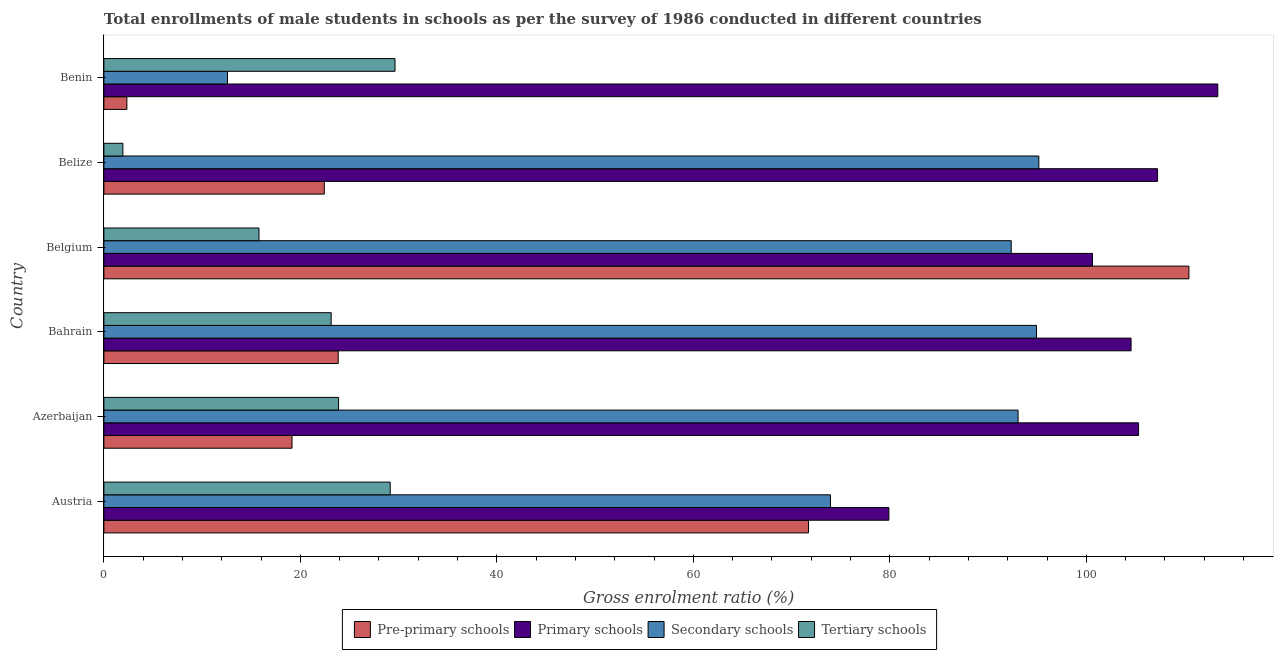Are the number of bars per tick equal to the number of legend labels?
Make the answer very short. Yes. Are the number of bars on each tick of the Y-axis equal?
Your answer should be compact. Yes. How many bars are there on the 4th tick from the top?
Your response must be concise. 4. How many bars are there on the 1st tick from the bottom?
Provide a short and direct response. 4. What is the label of the 2nd group of bars from the top?
Ensure brevity in your answer.  Belize. In how many cases, is the number of bars for a given country not equal to the number of legend labels?
Ensure brevity in your answer.  0. What is the gross enrolment ratio(male) in primary schools in Austria?
Your answer should be compact. 79.9. Across all countries, what is the maximum gross enrolment ratio(male) in primary schools?
Make the answer very short. 113.38. Across all countries, what is the minimum gross enrolment ratio(male) in pre-primary schools?
Provide a short and direct response. 2.34. In which country was the gross enrolment ratio(male) in primary schools maximum?
Provide a short and direct response. Benin. What is the total gross enrolment ratio(male) in pre-primary schools in the graph?
Give a very brief answer. 249.94. What is the difference between the gross enrolment ratio(male) in secondary schools in Belize and that in Benin?
Your answer should be compact. 82.59. What is the difference between the gross enrolment ratio(male) in primary schools in Benin and the gross enrolment ratio(male) in tertiary schools in Belgium?
Your answer should be compact. 97.59. What is the average gross enrolment ratio(male) in pre-primary schools per country?
Ensure brevity in your answer.  41.66. What is the difference between the gross enrolment ratio(male) in secondary schools and gross enrolment ratio(male) in pre-primary schools in Belgium?
Your response must be concise. -18.09. In how many countries, is the gross enrolment ratio(male) in tertiary schools greater than 36 %?
Offer a very short reply. 0. What is the ratio of the gross enrolment ratio(male) in pre-primary schools in Austria to that in Azerbaijan?
Keep it short and to the point. 3.75. Is the difference between the gross enrolment ratio(male) in secondary schools in Belgium and Belize greater than the difference between the gross enrolment ratio(male) in primary schools in Belgium and Belize?
Make the answer very short. Yes. What is the difference between the highest and the second highest gross enrolment ratio(male) in primary schools?
Offer a very short reply. 6.13. What is the difference between the highest and the lowest gross enrolment ratio(male) in tertiary schools?
Provide a succinct answer. 27.7. In how many countries, is the gross enrolment ratio(male) in tertiary schools greater than the average gross enrolment ratio(male) in tertiary schools taken over all countries?
Give a very brief answer. 4. Is it the case that in every country, the sum of the gross enrolment ratio(male) in pre-primary schools and gross enrolment ratio(male) in secondary schools is greater than the sum of gross enrolment ratio(male) in primary schools and gross enrolment ratio(male) in tertiary schools?
Your response must be concise. No. What does the 4th bar from the top in Belize represents?
Give a very brief answer. Pre-primary schools. What does the 3rd bar from the bottom in Belgium represents?
Offer a terse response. Secondary schools. Is it the case that in every country, the sum of the gross enrolment ratio(male) in pre-primary schools and gross enrolment ratio(male) in primary schools is greater than the gross enrolment ratio(male) in secondary schools?
Offer a terse response. Yes. How many countries are there in the graph?
Make the answer very short. 6. What is the difference between two consecutive major ticks on the X-axis?
Your answer should be compact. 20. Are the values on the major ticks of X-axis written in scientific E-notation?
Your answer should be very brief. No. Does the graph contain any zero values?
Provide a short and direct response. No. How are the legend labels stacked?
Make the answer very short. Horizontal. What is the title of the graph?
Offer a very short reply. Total enrollments of male students in schools as per the survey of 1986 conducted in different countries. Does "Finland" appear as one of the legend labels in the graph?
Keep it short and to the point. No. What is the Gross enrolment ratio (%) in Pre-primary schools in Austria?
Provide a short and direct response. 71.72. What is the Gross enrolment ratio (%) in Primary schools in Austria?
Your answer should be compact. 79.9. What is the Gross enrolment ratio (%) of Secondary schools in Austria?
Provide a succinct answer. 73.96. What is the Gross enrolment ratio (%) of Tertiary schools in Austria?
Provide a short and direct response. 29.14. What is the Gross enrolment ratio (%) of Pre-primary schools in Azerbaijan?
Provide a succinct answer. 19.15. What is the Gross enrolment ratio (%) of Primary schools in Azerbaijan?
Provide a short and direct response. 105.32. What is the Gross enrolment ratio (%) in Secondary schools in Azerbaijan?
Your response must be concise. 93.05. What is the Gross enrolment ratio (%) in Tertiary schools in Azerbaijan?
Ensure brevity in your answer.  23.89. What is the Gross enrolment ratio (%) of Pre-primary schools in Bahrain?
Offer a terse response. 23.85. What is the Gross enrolment ratio (%) in Primary schools in Bahrain?
Your answer should be very brief. 104.55. What is the Gross enrolment ratio (%) of Secondary schools in Bahrain?
Keep it short and to the point. 94.93. What is the Gross enrolment ratio (%) in Tertiary schools in Bahrain?
Your answer should be very brief. 23.13. What is the Gross enrolment ratio (%) in Pre-primary schools in Belgium?
Your answer should be compact. 110.44. What is the Gross enrolment ratio (%) in Primary schools in Belgium?
Make the answer very short. 100.63. What is the Gross enrolment ratio (%) in Secondary schools in Belgium?
Ensure brevity in your answer.  92.35. What is the Gross enrolment ratio (%) of Tertiary schools in Belgium?
Ensure brevity in your answer.  15.79. What is the Gross enrolment ratio (%) of Pre-primary schools in Belize?
Provide a short and direct response. 22.43. What is the Gross enrolment ratio (%) in Primary schools in Belize?
Your answer should be compact. 107.25. What is the Gross enrolment ratio (%) in Secondary schools in Belize?
Provide a short and direct response. 95.17. What is the Gross enrolment ratio (%) of Tertiary schools in Belize?
Make the answer very short. 1.93. What is the Gross enrolment ratio (%) of Pre-primary schools in Benin?
Provide a short and direct response. 2.34. What is the Gross enrolment ratio (%) in Primary schools in Benin?
Give a very brief answer. 113.38. What is the Gross enrolment ratio (%) of Secondary schools in Benin?
Make the answer very short. 12.58. What is the Gross enrolment ratio (%) of Tertiary schools in Benin?
Your answer should be compact. 29.63. Across all countries, what is the maximum Gross enrolment ratio (%) of Pre-primary schools?
Your answer should be compact. 110.44. Across all countries, what is the maximum Gross enrolment ratio (%) in Primary schools?
Offer a terse response. 113.38. Across all countries, what is the maximum Gross enrolment ratio (%) in Secondary schools?
Provide a short and direct response. 95.17. Across all countries, what is the maximum Gross enrolment ratio (%) in Tertiary schools?
Give a very brief answer. 29.63. Across all countries, what is the minimum Gross enrolment ratio (%) in Pre-primary schools?
Provide a succinct answer. 2.34. Across all countries, what is the minimum Gross enrolment ratio (%) in Primary schools?
Your answer should be very brief. 79.9. Across all countries, what is the minimum Gross enrolment ratio (%) of Secondary schools?
Keep it short and to the point. 12.58. Across all countries, what is the minimum Gross enrolment ratio (%) of Tertiary schools?
Provide a succinct answer. 1.93. What is the total Gross enrolment ratio (%) in Pre-primary schools in the graph?
Offer a terse response. 249.94. What is the total Gross enrolment ratio (%) in Primary schools in the graph?
Offer a terse response. 611.03. What is the total Gross enrolment ratio (%) in Secondary schools in the graph?
Offer a very short reply. 462.04. What is the total Gross enrolment ratio (%) in Tertiary schools in the graph?
Your answer should be very brief. 123.52. What is the difference between the Gross enrolment ratio (%) in Pre-primary schools in Austria and that in Azerbaijan?
Provide a succinct answer. 52.58. What is the difference between the Gross enrolment ratio (%) of Primary schools in Austria and that in Azerbaijan?
Offer a very short reply. -25.41. What is the difference between the Gross enrolment ratio (%) of Secondary schools in Austria and that in Azerbaijan?
Your answer should be very brief. -19.1. What is the difference between the Gross enrolment ratio (%) in Tertiary schools in Austria and that in Azerbaijan?
Offer a terse response. 5.26. What is the difference between the Gross enrolment ratio (%) in Pre-primary schools in Austria and that in Bahrain?
Provide a short and direct response. 47.87. What is the difference between the Gross enrolment ratio (%) in Primary schools in Austria and that in Bahrain?
Ensure brevity in your answer.  -24.65. What is the difference between the Gross enrolment ratio (%) in Secondary schools in Austria and that in Bahrain?
Keep it short and to the point. -20.97. What is the difference between the Gross enrolment ratio (%) of Tertiary schools in Austria and that in Bahrain?
Provide a short and direct response. 6.01. What is the difference between the Gross enrolment ratio (%) in Pre-primary schools in Austria and that in Belgium?
Your answer should be very brief. -38.72. What is the difference between the Gross enrolment ratio (%) of Primary schools in Austria and that in Belgium?
Provide a succinct answer. -20.73. What is the difference between the Gross enrolment ratio (%) of Secondary schools in Austria and that in Belgium?
Your answer should be compact. -18.4. What is the difference between the Gross enrolment ratio (%) in Tertiary schools in Austria and that in Belgium?
Keep it short and to the point. 13.36. What is the difference between the Gross enrolment ratio (%) in Pre-primary schools in Austria and that in Belize?
Offer a very short reply. 49.29. What is the difference between the Gross enrolment ratio (%) of Primary schools in Austria and that in Belize?
Ensure brevity in your answer.  -27.35. What is the difference between the Gross enrolment ratio (%) of Secondary schools in Austria and that in Belize?
Your answer should be very brief. -21.21. What is the difference between the Gross enrolment ratio (%) in Tertiary schools in Austria and that in Belize?
Your answer should be compact. 27.21. What is the difference between the Gross enrolment ratio (%) of Pre-primary schools in Austria and that in Benin?
Keep it short and to the point. 69.38. What is the difference between the Gross enrolment ratio (%) in Primary schools in Austria and that in Benin?
Give a very brief answer. -33.48. What is the difference between the Gross enrolment ratio (%) of Secondary schools in Austria and that in Benin?
Give a very brief answer. 61.38. What is the difference between the Gross enrolment ratio (%) in Tertiary schools in Austria and that in Benin?
Keep it short and to the point. -0.49. What is the difference between the Gross enrolment ratio (%) in Pre-primary schools in Azerbaijan and that in Bahrain?
Provide a short and direct response. -4.7. What is the difference between the Gross enrolment ratio (%) of Primary schools in Azerbaijan and that in Bahrain?
Offer a very short reply. 0.76. What is the difference between the Gross enrolment ratio (%) of Secondary schools in Azerbaijan and that in Bahrain?
Your answer should be compact. -1.88. What is the difference between the Gross enrolment ratio (%) of Tertiary schools in Azerbaijan and that in Bahrain?
Keep it short and to the point. 0.75. What is the difference between the Gross enrolment ratio (%) of Pre-primary schools in Azerbaijan and that in Belgium?
Your response must be concise. -91.29. What is the difference between the Gross enrolment ratio (%) of Primary schools in Azerbaijan and that in Belgium?
Offer a terse response. 4.69. What is the difference between the Gross enrolment ratio (%) in Secondary schools in Azerbaijan and that in Belgium?
Offer a terse response. 0.7. What is the difference between the Gross enrolment ratio (%) in Tertiary schools in Azerbaijan and that in Belgium?
Offer a very short reply. 8.1. What is the difference between the Gross enrolment ratio (%) of Pre-primary schools in Azerbaijan and that in Belize?
Your answer should be compact. -3.29. What is the difference between the Gross enrolment ratio (%) in Primary schools in Azerbaijan and that in Belize?
Your response must be concise. -1.93. What is the difference between the Gross enrolment ratio (%) of Secondary schools in Azerbaijan and that in Belize?
Keep it short and to the point. -2.11. What is the difference between the Gross enrolment ratio (%) of Tertiary schools in Azerbaijan and that in Belize?
Provide a short and direct response. 21.96. What is the difference between the Gross enrolment ratio (%) in Pre-primary schools in Azerbaijan and that in Benin?
Your answer should be compact. 16.81. What is the difference between the Gross enrolment ratio (%) in Primary schools in Azerbaijan and that in Benin?
Your answer should be very brief. -8.07. What is the difference between the Gross enrolment ratio (%) of Secondary schools in Azerbaijan and that in Benin?
Give a very brief answer. 80.47. What is the difference between the Gross enrolment ratio (%) in Tertiary schools in Azerbaijan and that in Benin?
Your response must be concise. -5.75. What is the difference between the Gross enrolment ratio (%) of Pre-primary schools in Bahrain and that in Belgium?
Your response must be concise. -86.59. What is the difference between the Gross enrolment ratio (%) of Primary schools in Bahrain and that in Belgium?
Offer a terse response. 3.93. What is the difference between the Gross enrolment ratio (%) in Secondary schools in Bahrain and that in Belgium?
Your answer should be compact. 2.57. What is the difference between the Gross enrolment ratio (%) in Tertiary schools in Bahrain and that in Belgium?
Keep it short and to the point. 7.35. What is the difference between the Gross enrolment ratio (%) in Pre-primary schools in Bahrain and that in Belize?
Provide a succinct answer. 1.42. What is the difference between the Gross enrolment ratio (%) of Primary schools in Bahrain and that in Belize?
Keep it short and to the point. -2.7. What is the difference between the Gross enrolment ratio (%) in Secondary schools in Bahrain and that in Belize?
Provide a short and direct response. -0.24. What is the difference between the Gross enrolment ratio (%) in Tertiary schools in Bahrain and that in Belize?
Keep it short and to the point. 21.2. What is the difference between the Gross enrolment ratio (%) in Pre-primary schools in Bahrain and that in Benin?
Provide a succinct answer. 21.51. What is the difference between the Gross enrolment ratio (%) of Primary schools in Bahrain and that in Benin?
Ensure brevity in your answer.  -8.83. What is the difference between the Gross enrolment ratio (%) in Secondary schools in Bahrain and that in Benin?
Give a very brief answer. 82.35. What is the difference between the Gross enrolment ratio (%) in Tertiary schools in Bahrain and that in Benin?
Offer a very short reply. -6.5. What is the difference between the Gross enrolment ratio (%) in Pre-primary schools in Belgium and that in Belize?
Offer a very short reply. 88.01. What is the difference between the Gross enrolment ratio (%) in Primary schools in Belgium and that in Belize?
Your response must be concise. -6.62. What is the difference between the Gross enrolment ratio (%) in Secondary schools in Belgium and that in Belize?
Your response must be concise. -2.81. What is the difference between the Gross enrolment ratio (%) of Tertiary schools in Belgium and that in Belize?
Offer a terse response. 13.85. What is the difference between the Gross enrolment ratio (%) in Pre-primary schools in Belgium and that in Benin?
Provide a short and direct response. 108.1. What is the difference between the Gross enrolment ratio (%) of Primary schools in Belgium and that in Benin?
Your response must be concise. -12.75. What is the difference between the Gross enrolment ratio (%) of Secondary schools in Belgium and that in Benin?
Make the answer very short. 79.77. What is the difference between the Gross enrolment ratio (%) of Tertiary schools in Belgium and that in Benin?
Provide a short and direct response. -13.85. What is the difference between the Gross enrolment ratio (%) in Pre-primary schools in Belize and that in Benin?
Ensure brevity in your answer.  20.09. What is the difference between the Gross enrolment ratio (%) in Primary schools in Belize and that in Benin?
Provide a succinct answer. -6.13. What is the difference between the Gross enrolment ratio (%) in Secondary schools in Belize and that in Benin?
Provide a short and direct response. 82.59. What is the difference between the Gross enrolment ratio (%) of Tertiary schools in Belize and that in Benin?
Your answer should be very brief. -27.7. What is the difference between the Gross enrolment ratio (%) of Pre-primary schools in Austria and the Gross enrolment ratio (%) of Primary schools in Azerbaijan?
Ensure brevity in your answer.  -33.59. What is the difference between the Gross enrolment ratio (%) in Pre-primary schools in Austria and the Gross enrolment ratio (%) in Secondary schools in Azerbaijan?
Ensure brevity in your answer.  -21.33. What is the difference between the Gross enrolment ratio (%) of Pre-primary schools in Austria and the Gross enrolment ratio (%) of Tertiary schools in Azerbaijan?
Keep it short and to the point. 47.84. What is the difference between the Gross enrolment ratio (%) of Primary schools in Austria and the Gross enrolment ratio (%) of Secondary schools in Azerbaijan?
Your answer should be very brief. -13.15. What is the difference between the Gross enrolment ratio (%) of Primary schools in Austria and the Gross enrolment ratio (%) of Tertiary schools in Azerbaijan?
Offer a terse response. 56.01. What is the difference between the Gross enrolment ratio (%) of Secondary schools in Austria and the Gross enrolment ratio (%) of Tertiary schools in Azerbaijan?
Give a very brief answer. 50.07. What is the difference between the Gross enrolment ratio (%) in Pre-primary schools in Austria and the Gross enrolment ratio (%) in Primary schools in Bahrain?
Ensure brevity in your answer.  -32.83. What is the difference between the Gross enrolment ratio (%) in Pre-primary schools in Austria and the Gross enrolment ratio (%) in Secondary schools in Bahrain?
Your answer should be very brief. -23.21. What is the difference between the Gross enrolment ratio (%) in Pre-primary schools in Austria and the Gross enrolment ratio (%) in Tertiary schools in Bahrain?
Provide a short and direct response. 48.59. What is the difference between the Gross enrolment ratio (%) in Primary schools in Austria and the Gross enrolment ratio (%) in Secondary schools in Bahrain?
Provide a short and direct response. -15.03. What is the difference between the Gross enrolment ratio (%) of Primary schools in Austria and the Gross enrolment ratio (%) of Tertiary schools in Bahrain?
Offer a very short reply. 56.77. What is the difference between the Gross enrolment ratio (%) of Secondary schools in Austria and the Gross enrolment ratio (%) of Tertiary schools in Bahrain?
Offer a very short reply. 50.82. What is the difference between the Gross enrolment ratio (%) in Pre-primary schools in Austria and the Gross enrolment ratio (%) in Primary schools in Belgium?
Keep it short and to the point. -28.9. What is the difference between the Gross enrolment ratio (%) in Pre-primary schools in Austria and the Gross enrolment ratio (%) in Secondary schools in Belgium?
Provide a short and direct response. -20.63. What is the difference between the Gross enrolment ratio (%) of Pre-primary schools in Austria and the Gross enrolment ratio (%) of Tertiary schools in Belgium?
Your answer should be very brief. 55.94. What is the difference between the Gross enrolment ratio (%) of Primary schools in Austria and the Gross enrolment ratio (%) of Secondary schools in Belgium?
Give a very brief answer. -12.45. What is the difference between the Gross enrolment ratio (%) of Primary schools in Austria and the Gross enrolment ratio (%) of Tertiary schools in Belgium?
Offer a terse response. 64.11. What is the difference between the Gross enrolment ratio (%) in Secondary schools in Austria and the Gross enrolment ratio (%) in Tertiary schools in Belgium?
Offer a very short reply. 58.17. What is the difference between the Gross enrolment ratio (%) in Pre-primary schools in Austria and the Gross enrolment ratio (%) in Primary schools in Belize?
Your response must be concise. -35.53. What is the difference between the Gross enrolment ratio (%) in Pre-primary schools in Austria and the Gross enrolment ratio (%) in Secondary schools in Belize?
Your response must be concise. -23.44. What is the difference between the Gross enrolment ratio (%) of Pre-primary schools in Austria and the Gross enrolment ratio (%) of Tertiary schools in Belize?
Your answer should be compact. 69.79. What is the difference between the Gross enrolment ratio (%) of Primary schools in Austria and the Gross enrolment ratio (%) of Secondary schools in Belize?
Ensure brevity in your answer.  -15.27. What is the difference between the Gross enrolment ratio (%) in Primary schools in Austria and the Gross enrolment ratio (%) in Tertiary schools in Belize?
Provide a short and direct response. 77.97. What is the difference between the Gross enrolment ratio (%) of Secondary schools in Austria and the Gross enrolment ratio (%) of Tertiary schools in Belize?
Offer a very short reply. 72.02. What is the difference between the Gross enrolment ratio (%) of Pre-primary schools in Austria and the Gross enrolment ratio (%) of Primary schools in Benin?
Ensure brevity in your answer.  -41.66. What is the difference between the Gross enrolment ratio (%) of Pre-primary schools in Austria and the Gross enrolment ratio (%) of Secondary schools in Benin?
Keep it short and to the point. 59.14. What is the difference between the Gross enrolment ratio (%) in Pre-primary schools in Austria and the Gross enrolment ratio (%) in Tertiary schools in Benin?
Offer a very short reply. 42.09. What is the difference between the Gross enrolment ratio (%) of Primary schools in Austria and the Gross enrolment ratio (%) of Secondary schools in Benin?
Keep it short and to the point. 67.32. What is the difference between the Gross enrolment ratio (%) in Primary schools in Austria and the Gross enrolment ratio (%) in Tertiary schools in Benin?
Your answer should be compact. 50.27. What is the difference between the Gross enrolment ratio (%) in Secondary schools in Austria and the Gross enrolment ratio (%) in Tertiary schools in Benin?
Your answer should be compact. 44.32. What is the difference between the Gross enrolment ratio (%) of Pre-primary schools in Azerbaijan and the Gross enrolment ratio (%) of Primary schools in Bahrain?
Your response must be concise. -85.41. What is the difference between the Gross enrolment ratio (%) in Pre-primary schools in Azerbaijan and the Gross enrolment ratio (%) in Secondary schools in Bahrain?
Make the answer very short. -75.78. What is the difference between the Gross enrolment ratio (%) of Pre-primary schools in Azerbaijan and the Gross enrolment ratio (%) of Tertiary schools in Bahrain?
Provide a succinct answer. -3.99. What is the difference between the Gross enrolment ratio (%) of Primary schools in Azerbaijan and the Gross enrolment ratio (%) of Secondary schools in Bahrain?
Give a very brief answer. 10.39. What is the difference between the Gross enrolment ratio (%) in Primary schools in Azerbaijan and the Gross enrolment ratio (%) in Tertiary schools in Bahrain?
Offer a very short reply. 82.18. What is the difference between the Gross enrolment ratio (%) of Secondary schools in Azerbaijan and the Gross enrolment ratio (%) of Tertiary schools in Bahrain?
Make the answer very short. 69.92. What is the difference between the Gross enrolment ratio (%) of Pre-primary schools in Azerbaijan and the Gross enrolment ratio (%) of Primary schools in Belgium?
Provide a short and direct response. -81.48. What is the difference between the Gross enrolment ratio (%) in Pre-primary schools in Azerbaijan and the Gross enrolment ratio (%) in Secondary schools in Belgium?
Ensure brevity in your answer.  -73.21. What is the difference between the Gross enrolment ratio (%) of Pre-primary schools in Azerbaijan and the Gross enrolment ratio (%) of Tertiary schools in Belgium?
Offer a very short reply. 3.36. What is the difference between the Gross enrolment ratio (%) of Primary schools in Azerbaijan and the Gross enrolment ratio (%) of Secondary schools in Belgium?
Keep it short and to the point. 12.96. What is the difference between the Gross enrolment ratio (%) of Primary schools in Azerbaijan and the Gross enrolment ratio (%) of Tertiary schools in Belgium?
Provide a short and direct response. 89.53. What is the difference between the Gross enrolment ratio (%) of Secondary schools in Azerbaijan and the Gross enrolment ratio (%) of Tertiary schools in Belgium?
Offer a terse response. 77.27. What is the difference between the Gross enrolment ratio (%) of Pre-primary schools in Azerbaijan and the Gross enrolment ratio (%) of Primary schools in Belize?
Provide a succinct answer. -88.1. What is the difference between the Gross enrolment ratio (%) of Pre-primary schools in Azerbaijan and the Gross enrolment ratio (%) of Secondary schools in Belize?
Provide a short and direct response. -76.02. What is the difference between the Gross enrolment ratio (%) of Pre-primary schools in Azerbaijan and the Gross enrolment ratio (%) of Tertiary schools in Belize?
Keep it short and to the point. 17.22. What is the difference between the Gross enrolment ratio (%) of Primary schools in Azerbaijan and the Gross enrolment ratio (%) of Secondary schools in Belize?
Provide a short and direct response. 10.15. What is the difference between the Gross enrolment ratio (%) in Primary schools in Azerbaijan and the Gross enrolment ratio (%) in Tertiary schools in Belize?
Provide a succinct answer. 103.38. What is the difference between the Gross enrolment ratio (%) in Secondary schools in Azerbaijan and the Gross enrolment ratio (%) in Tertiary schools in Belize?
Keep it short and to the point. 91.12. What is the difference between the Gross enrolment ratio (%) in Pre-primary schools in Azerbaijan and the Gross enrolment ratio (%) in Primary schools in Benin?
Provide a succinct answer. -94.23. What is the difference between the Gross enrolment ratio (%) of Pre-primary schools in Azerbaijan and the Gross enrolment ratio (%) of Secondary schools in Benin?
Your answer should be compact. 6.57. What is the difference between the Gross enrolment ratio (%) in Pre-primary schools in Azerbaijan and the Gross enrolment ratio (%) in Tertiary schools in Benin?
Offer a terse response. -10.49. What is the difference between the Gross enrolment ratio (%) in Primary schools in Azerbaijan and the Gross enrolment ratio (%) in Secondary schools in Benin?
Your response must be concise. 92.74. What is the difference between the Gross enrolment ratio (%) in Primary schools in Azerbaijan and the Gross enrolment ratio (%) in Tertiary schools in Benin?
Your response must be concise. 75.68. What is the difference between the Gross enrolment ratio (%) in Secondary schools in Azerbaijan and the Gross enrolment ratio (%) in Tertiary schools in Benin?
Give a very brief answer. 63.42. What is the difference between the Gross enrolment ratio (%) in Pre-primary schools in Bahrain and the Gross enrolment ratio (%) in Primary schools in Belgium?
Make the answer very short. -76.78. What is the difference between the Gross enrolment ratio (%) in Pre-primary schools in Bahrain and the Gross enrolment ratio (%) in Secondary schools in Belgium?
Your answer should be very brief. -68.5. What is the difference between the Gross enrolment ratio (%) of Pre-primary schools in Bahrain and the Gross enrolment ratio (%) of Tertiary schools in Belgium?
Your response must be concise. 8.06. What is the difference between the Gross enrolment ratio (%) in Primary schools in Bahrain and the Gross enrolment ratio (%) in Secondary schools in Belgium?
Your answer should be compact. 12.2. What is the difference between the Gross enrolment ratio (%) in Primary schools in Bahrain and the Gross enrolment ratio (%) in Tertiary schools in Belgium?
Give a very brief answer. 88.77. What is the difference between the Gross enrolment ratio (%) in Secondary schools in Bahrain and the Gross enrolment ratio (%) in Tertiary schools in Belgium?
Provide a succinct answer. 79.14. What is the difference between the Gross enrolment ratio (%) of Pre-primary schools in Bahrain and the Gross enrolment ratio (%) of Primary schools in Belize?
Make the answer very short. -83.4. What is the difference between the Gross enrolment ratio (%) in Pre-primary schools in Bahrain and the Gross enrolment ratio (%) in Secondary schools in Belize?
Provide a short and direct response. -71.32. What is the difference between the Gross enrolment ratio (%) of Pre-primary schools in Bahrain and the Gross enrolment ratio (%) of Tertiary schools in Belize?
Keep it short and to the point. 21.92. What is the difference between the Gross enrolment ratio (%) in Primary schools in Bahrain and the Gross enrolment ratio (%) in Secondary schools in Belize?
Offer a terse response. 9.39. What is the difference between the Gross enrolment ratio (%) of Primary schools in Bahrain and the Gross enrolment ratio (%) of Tertiary schools in Belize?
Offer a very short reply. 102.62. What is the difference between the Gross enrolment ratio (%) in Secondary schools in Bahrain and the Gross enrolment ratio (%) in Tertiary schools in Belize?
Make the answer very short. 93. What is the difference between the Gross enrolment ratio (%) in Pre-primary schools in Bahrain and the Gross enrolment ratio (%) in Primary schools in Benin?
Your answer should be compact. -89.53. What is the difference between the Gross enrolment ratio (%) of Pre-primary schools in Bahrain and the Gross enrolment ratio (%) of Secondary schools in Benin?
Offer a very short reply. 11.27. What is the difference between the Gross enrolment ratio (%) of Pre-primary schools in Bahrain and the Gross enrolment ratio (%) of Tertiary schools in Benin?
Give a very brief answer. -5.78. What is the difference between the Gross enrolment ratio (%) of Primary schools in Bahrain and the Gross enrolment ratio (%) of Secondary schools in Benin?
Provide a short and direct response. 91.97. What is the difference between the Gross enrolment ratio (%) of Primary schools in Bahrain and the Gross enrolment ratio (%) of Tertiary schools in Benin?
Make the answer very short. 74.92. What is the difference between the Gross enrolment ratio (%) in Secondary schools in Bahrain and the Gross enrolment ratio (%) in Tertiary schools in Benin?
Offer a terse response. 65.3. What is the difference between the Gross enrolment ratio (%) in Pre-primary schools in Belgium and the Gross enrolment ratio (%) in Primary schools in Belize?
Your response must be concise. 3.19. What is the difference between the Gross enrolment ratio (%) in Pre-primary schools in Belgium and the Gross enrolment ratio (%) in Secondary schools in Belize?
Give a very brief answer. 15.28. What is the difference between the Gross enrolment ratio (%) of Pre-primary schools in Belgium and the Gross enrolment ratio (%) of Tertiary schools in Belize?
Your answer should be compact. 108.51. What is the difference between the Gross enrolment ratio (%) of Primary schools in Belgium and the Gross enrolment ratio (%) of Secondary schools in Belize?
Keep it short and to the point. 5.46. What is the difference between the Gross enrolment ratio (%) in Primary schools in Belgium and the Gross enrolment ratio (%) in Tertiary schools in Belize?
Keep it short and to the point. 98.7. What is the difference between the Gross enrolment ratio (%) of Secondary schools in Belgium and the Gross enrolment ratio (%) of Tertiary schools in Belize?
Make the answer very short. 90.42. What is the difference between the Gross enrolment ratio (%) of Pre-primary schools in Belgium and the Gross enrolment ratio (%) of Primary schools in Benin?
Ensure brevity in your answer.  -2.94. What is the difference between the Gross enrolment ratio (%) of Pre-primary schools in Belgium and the Gross enrolment ratio (%) of Secondary schools in Benin?
Offer a terse response. 97.86. What is the difference between the Gross enrolment ratio (%) of Pre-primary schools in Belgium and the Gross enrolment ratio (%) of Tertiary schools in Benin?
Provide a short and direct response. 80.81. What is the difference between the Gross enrolment ratio (%) of Primary schools in Belgium and the Gross enrolment ratio (%) of Secondary schools in Benin?
Ensure brevity in your answer.  88.05. What is the difference between the Gross enrolment ratio (%) of Primary schools in Belgium and the Gross enrolment ratio (%) of Tertiary schools in Benin?
Ensure brevity in your answer.  71. What is the difference between the Gross enrolment ratio (%) in Secondary schools in Belgium and the Gross enrolment ratio (%) in Tertiary schools in Benin?
Give a very brief answer. 62.72. What is the difference between the Gross enrolment ratio (%) of Pre-primary schools in Belize and the Gross enrolment ratio (%) of Primary schools in Benin?
Your response must be concise. -90.95. What is the difference between the Gross enrolment ratio (%) in Pre-primary schools in Belize and the Gross enrolment ratio (%) in Secondary schools in Benin?
Your answer should be very brief. 9.85. What is the difference between the Gross enrolment ratio (%) of Pre-primary schools in Belize and the Gross enrolment ratio (%) of Tertiary schools in Benin?
Your answer should be compact. -7.2. What is the difference between the Gross enrolment ratio (%) of Primary schools in Belize and the Gross enrolment ratio (%) of Secondary schools in Benin?
Offer a very short reply. 94.67. What is the difference between the Gross enrolment ratio (%) of Primary schools in Belize and the Gross enrolment ratio (%) of Tertiary schools in Benin?
Your answer should be compact. 77.62. What is the difference between the Gross enrolment ratio (%) of Secondary schools in Belize and the Gross enrolment ratio (%) of Tertiary schools in Benin?
Provide a succinct answer. 65.53. What is the average Gross enrolment ratio (%) in Pre-primary schools per country?
Provide a short and direct response. 41.66. What is the average Gross enrolment ratio (%) of Primary schools per country?
Your response must be concise. 101.84. What is the average Gross enrolment ratio (%) in Secondary schools per country?
Make the answer very short. 77.01. What is the average Gross enrolment ratio (%) in Tertiary schools per country?
Keep it short and to the point. 20.59. What is the difference between the Gross enrolment ratio (%) in Pre-primary schools and Gross enrolment ratio (%) in Primary schools in Austria?
Keep it short and to the point. -8.18. What is the difference between the Gross enrolment ratio (%) of Pre-primary schools and Gross enrolment ratio (%) of Secondary schools in Austria?
Provide a succinct answer. -2.23. What is the difference between the Gross enrolment ratio (%) in Pre-primary schools and Gross enrolment ratio (%) in Tertiary schools in Austria?
Make the answer very short. 42.58. What is the difference between the Gross enrolment ratio (%) of Primary schools and Gross enrolment ratio (%) of Secondary schools in Austria?
Offer a very short reply. 5.95. What is the difference between the Gross enrolment ratio (%) of Primary schools and Gross enrolment ratio (%) of Tertiary schools in Austria?
Provide a short and direct response. 50.76. What is the difference between the Gross enrolment ratio (%) of Secondary schools and Gross enrolment ratio (%) of Tertiary schools in Austria?
Your answer should be very brief. 44.81. What is the difference between the Gross enrolment ratio (%) in Pre-primary schools and Gross enrolment ratio (%) in Primary schools in Azerbaijan?
Offer a terse response. -86.17. What is the difference between the Gross enrolment ratio (%) of Pre-primary schools and Gross enrolment ratio (%) of Secondary schools in Azerbaijan?
Offer a very short reply. -73.9. What is the difference between the Gross enrolment ratio (%) in Pre-primary schools and Gross enrolment ratio (%) in Tertiary schools in Azerbaijan?
Make the answer very short. -4.74. What is the difference between the Gross enrolment ratio (%) in Primary schools and Gross enrolment ratio (%) in Secondary schools in Azerbaijan?
Give a very brief answer. 12.26. What is the difference between the Gross enrolment ratio (%) in Primary schools and Gross enrolment ratio (%) in Tertiary schools in Azerbaijan?
Ensure brevity in your answer.  81.43. What is the difference between the Gross enrolment ratio (%) in Secondary schools and Gross enrolment ratio (%) in Tertiary schools in Azerbaijan?
Give a very brief answer. 69.16. What is the difference between the Gross enrolment ratio (%) of Pre-primary schools and Gross enrolment ratio (%) of Primary schools in Bahrain?
Keep it short and to the point. -80.7. What is the difference between the Gross enrolment ratio (%) in Pre-primary schools and Gross enrolment ratio (%) in Secondary schools in Bahrain?
Your response must be concise. -71.08. What is the difference between the Gross enrolment ratio (%) in Pre-primary schools and Gross enrolment ratio (%) in Tertiary schools in Bahrain?
Provide a succinct answer. 0.72. What is the difference between the Gross enrolment ratio (%) of Primary schools and Gross enrolment ratio (%) of Secondary schools in Bahrain?
Provide a succinct answer. 9.62. What is the difference between the Gross enrolment ratio (%) of Primary schools and Gross enrolment ratio (%) of Tertiary schools in Bahrain?
Your response must be concise. 81.42. What is the difference between the Gross enrolment ratio (%) in Secondary schools and Gross enrolment ratio (%) in Tertiary schools in Bahrain?
Provide a short and direct response. 71.8. What is the difference between the Gross enrolment ratio (%) of Pre-primary schools and Gross enrolment ratio (%) of Primary schools in Belgium?
Ensure brevity in your answer.  9.81. What is the difference between the Gross enrolment ratio (%) of Pre-primary schools and Gross enrolment ratio (%) of Secondary schools in Belgium?
Your response must be concise. 18.09. What is the difference between the Gross enrolment ratio (%) in Pre-primary schools and Gross enrolment ratio (%) in Tertiary schools in Belgium?
Ensure brevity in your answer.  94.66. What is the difference between the Gross enrolment ratio (%) of Primary schools and Gross enrolment ratio (%) of Secondary schools in Belgium?
Keep it short and to the point. 8.27. What is the difference between the Gross enrolment ratio (%) in Primary schools and Gross enrolment ratio (%) in Tertiary schools in Belgium?
Your answer should be compact. 84.84. What is the difference between the Gross enrolment ratio (%) in Secondary schools and Gross enrolment ratio (%) in Tertiary schools in Belgium?
Offer a very short reply. 76.57. What is the difference between the Gross enrolment ratio (%) in Pre-primary schools and Gross enrolment ratio (%) in Primary schools in Belize?
Give a very brief answer. -84.81. What is the difference between the Gross enrolment ratio (%) in Pre-primary schools and Gross enrolment ratio (%) in Secondary schools in Belize?
Keep it short and to the point. -72.73. What is the difference between the Gross enrolment ratio (%) in Pre-primary schools and Gross enrolment ratio (%) in Tertiary schools in Belize?
Provide a succinct answer. 20.5. What is the difference between the Gross enrolment ratio (%) of Primary schools and Gross enrolment ratio (%) of Secondary schools in Belize?
Provide a succinct answer. 12.08. What is the difference between the Gross enrolment ratio (%) of Primary schools and Gross enrolment ratio (%) of Tertiary schools in Belize?
Offer a terse response. 105.32. What is the difference between the Gross enrolment ratio (%) in Secondary schools and Gross enrolment ratio (%) in Tertiary schools in Belize?
Offer a terse response. 93.23. What is the difference between the Gross enrolment ratio (%) of Pre-primary schools and Gross enrolment ratio (%) of Primary schools in Benin?
Offer a very short reply. -111.04. What is the difference between the Gross enrolment ratio (%) of Pre-primary schools and Gross enrolment ratio (%) of Secondary schools in Benin?
Make the answer very short. -10.24. What is the difference between the Gross enrolment ratio (%) of Pre-primary schools and Gross enrolment ratio (%) of Tertiary schools in Benin?
Provide a succinct answer. -27.29. What is the difference between the Gross enrolment ratio (%) of Primary schools and Gross enrolment ratio (%) of Secondary schools in Benin?
Provide a succinct answer. 100.8. What is the difference between the Gross enrolment ratio (%) in Primary schools and Gross enrolment ratio (%) in Tertiary schools in Benin?
Give a very brief answer. 83.75. What is the difference between the Gross enrolment ratio (%) of Secondary schools and Gross enrolment ratio (%) of Tertiary schools in Benin?
Your answer should be very brief. -17.05. What is the ratio of the Gross enrolment ratio (%) of Pre-primary schools in Austria to that in Azerbaijan?
Ensure brevity in your answer.  3.75. What is the ratio of the Gross enrolment ratio (%) of Primary schools in Austria to that in Azerbaijan?
Your answer should be compact. 0.76. What is the ratio of the Gross enrolment ratio (%) in Secondary schools in Austria to that in Azerbaijan?
Ensure brevity in your answer.  0.79. What is the ratio of the Gross enrolment ratio (%) in Tertiary schools in Austria to that in Azerbaijan?
Your answer should be compact. 1.22. What is the ratio of the Gross enrolment ratio (%) of Pre-primary schools in Austria to that in Bahrain?
Provide a succinct answer. 3.01. What is the ratio of the Gross enrolment ratio (%) of Primary schools in Austria to that in Bahrain?
Make the answer very short. 0.76. What is the ratio of the Gross enrolment ratio (%) in Secondary schools in Austria to that in Bahrain?
Make the answer very short. 0.78. What is the ratio of the Gross enrolment ratio (%) in Tertiary schools in Austria to that in Bahrain?
Your answer should be very brief. 1.26. What is the ratio of the Gross enrolment ratio (%) in Pre-primary schools in Austria to that in Belgium?
Provide a succinct answer. 0.65. What is the ratio of the Gross enrolment ratio (%) in Primary schools in Austria to that in Belgium?
Provide a short and direct response. 0.79. What is the ratio of the Gross enrolment ratio (%) in Secondary schools in Austria to that in Belgium?
Make the answer very short. 0.8. What is the ratio of the Gross enrolment ratio (%) in Tertiary schools in Austria to that in Belgium?
Offer a terse response. 1.85. What is the ratio of the Gross enrolment ratio (%) of Pre-primary schools in Austria to that in Belize?
Offer a terse response. 3.2. What is the ratio of the Gross enrolment ratio (%) in Primary schools in Austria to that in Belize?
Offer a terse response. 0.74. What is the ratio of the Gross enrolment ratio (%) in Secondary schools in Austria to that in Belize?
Provide a short and direct response. 0.78. What is the ratio of the Gross enrolment ratio (%) of Tertiary schools in Austria to that in Belize?
Keep it short and to the point. 15.08. What is the ratio of the Gross enrolment ratio (%) of Pre-primary schools in Austria to that in Benin?
Your answer should be compact. 30.65. What is the ratio of the Gross enrolment ratio (%) of Primary schools in Austria to that in Benin?
Your answer should be very brief. 0.7. What is the ratio of the Gross enrolment ratio (%) in Secondary schools in Austria to that in Benin?
Give a very brief answer. 5.88. What is the ratio of the Gross enrolment ratio (%) in Tertiary schools in Austria to that in Benin?
Offer a terse response. 0.98. What is the ratio of the Gross enrolment ratio (%) in Pre-primary schools in Azerbaijan to that in Bahrain?
Provide a succinct answer. 0.8. What is the ratio of the Gross enrolment ratio (%) of Primary schools in Azerbaijan to that in Bahrain?
Offer a very short reply. 1.01. What is the ratio of the Gross enrolment ratio (%) in Secondary schools in Azerbaijan to that in Bahrain?
Your answer should be very brief. 0.98. What is the ratio of the Gross enrolment ratio (%) of Tertiary schools in Azerbaijan to that in Bahrain?
Provide a succinct answer. 1.03. What is the ratio of the Gross enrolment ratio (%) of Pre-primary schools in Azerbaijan to that in Belgium?
Ensure brevity in your answer.  0.17. What is the ratio of the Gross enrolment ratio (%) of Primary schools in Azerbaijan to that in Belgium?
Make the answer very short. 1.05. What is the ratio of the Gross enrolment ratio (%) of Secondary schools in Azerbaijan to that in Belgium?
Provide a succinct answer. 1.01. What is the ratio of the Gross enrolment ratio (%) of Tertiary schools in Azerbaijan to that in Belgium?
Your answer should be compact. 1.51. What is the ratio of the Gross enrolment ratio (%) of Pre-primary schools in Azerbaijan to that in Belize?
Your answer should be compact. 0.85. What is the ratio of the Gross enrolment ratio (%) of Primary schools in Azerbaijan to that in Belize?
Ensure brevity in your answer.  0.98. What is the ratio of the Gross enrolment ratio (%) of Secondary schools in Azerbaijan to that in Belize?
Your answer should be compact. 0.98. What is the ratio of the Gross enrolment ratio (%) in Tertiary schools in Azerbaijan to that in Belize?
Offer a very short reply. 12.36. What is the ratio of the Gross enrolment ratio (%) in Pre-primary schools in Azerbaijan to that in Benin?
Provide a short and direct response. 8.18. What is the ratio of the Gross enrolment ratio (%) in Primary schools in Azerbaijan to that in Benin?
Make the answer very short. 0.93. What is the ratio of the Gross enrolment ratio (%) of Secondary schools in Azerbaijan to that in Benin?
Offer a terse response. 7.4. What is the ratio of the Gross enrolment ratio (%) of Tertiary schools in Azerbaijan to that in Benin?
Give a very brief answer. 0.81. What is the ratio of the Gross enrolment ratio (%) of Pre-primary schools in Bahrain to that in Belgium?
Your answer should be compact. 0.22. What is the ratio of the Gross enrolment ratio (%) in Primary schools in Bahrain to that in Belgium?
Provide a succinct answer. 1.04. What is the ratio of the Gross enrolment ratio (%) in Secondary schools in Bahrain to that in Belgium?
Provide a succinct answer. 1.03. What is the ratio of the Gross enrolment ratio (%) of Tertiary schools in Bahrain to that in Belgium?
Offer a very short reply. 1.47. What is the ratio of the Gross enrolment ratio (%) of Pre-primary schools in Bahrain to that in Belize?
Make the answer very short. 1.06. What is the ratio of the Gross enrolment ratio (%) of Primary schools in Bahrain to that in Belize?
Your answer should be very brief. 0.97. What is the ratio of the Gross enrolment ratio (%) in Secondary schools in Bahrain to that in Belize?
Give a very brief answer. 1. What is the ratio of the Gross enrolment ratio (%) of Tertiary schools in Bahrain to that in Belize?
Your response must be concise. 11.97. What is the ratio of the Gross enrolment ratio (%) of Pre-primary schools in Bahrain to that in Benin?
Your response must be concise. 10.19. What is the ratio of the Gross enrolment ratio (%) in Primary schools in Bahrain to that in Benin?
Your answer should be very brief. 0.92. What is the ratio of the Gross enrolment ratio (%) in Secondary schools in Bahrain to that in Benin?
Make the answer very short. 7.55. What is the ratio of the Gross enrolment ratio (%) in Tertiary schools in Bahrain to that in Benin?
Your answer should be compact. 0.78. What is the ratio of the Gross enrolment ratio (%) in Pre-primary schools in Belgium to that in Belize?
Offer a very short reply. 4.92. What is the ratio of the Gross enrolment ratio (%) in Primary schools in Belgium to that in Belize?
Ensure brevity in your answer.  0.94. What is the ratio of the Gross enrolment ratio (%) in Secondary schools in Belgium to that in Belize?
Provide a succinct answer. 0.97. What is the ratio of the Gross enrolment ratio (%) in Tertiary schools in Belgium to that in Belize?
Provide a short and direct response. 8.17. What is the ratio of the Gross enrolment ratio (%) in Pre-primary schools in Belgium to that in Benin?
Provide a succinct answer. 47.2. What is the ratio of the Gross enrolment ratio (%) of Primary schools in Belgium to that in Benin?
Provide a short and direct response. 0.89. What is the ratio of the Gross enrolment ratio (%) in Secondary schools in Belgium to that in Benin?
Offer a terse response. 7.34. What is the ratio of the Gross enrolment ratio (%) of Tertiary schools in Belgium to that in Benin?
Your response must be concise. 0.53. What is the ratio of the Gross enrolment ratio (%) in Pre-primary schools in Belize to that in Benin?
Keep it short and to the point. 9.59. What is the ratio of the Gross enrolment ratio (%) in Primary schools in Belize to that in Benin?
Your response must be concise. 0.95. What is the ratio of the Gross enrolment ratio (%) in Secondary schools in Belize to that in Benin?
Make the answer very short. 7.56. What is the ratio of the Gross enrolment ratio (%) of Tertiary schools in Belize to that in Benin?
Make the answer very short. 0.07. What is the difference between the highest and the second highest Gross enrolment ratio (%) in Pre-primary schools?
Provide a succinct answer. 38.72. What is the difference between the highest and the second highest Gross enrolment ratio (%) in Primary schools?
Ensure brevity in your answer.  6.13. What is the difference between the highest and the second highest Gross enrolment ratio (%) of Secondary schools?
Provide a short and direct response. 0.24. What is the difference between the highest and the second highest Gross enrolment ratio (%) of Tertiary schools?
Provide a succinct answer. 0.49. What is the difference between the highest and the lowest Gross enrolment ratio (%) in Pre-primary schools?
Make the answer very short. 108.1. What is the difference between the highest and the lowest Gross enrolment ratio (%) in Primary schools?
Provide a succinct answer. 33.48. What is the difference between the highest and the lowest Gross enrolment ratio (%) of Secondary schools?
Provide a short and direct response. 82.59. What is the difference between the highest and the lowest Gross enrolment ratio (%) of Tertiary schools?
Provide a short and direct response. 27.7. 